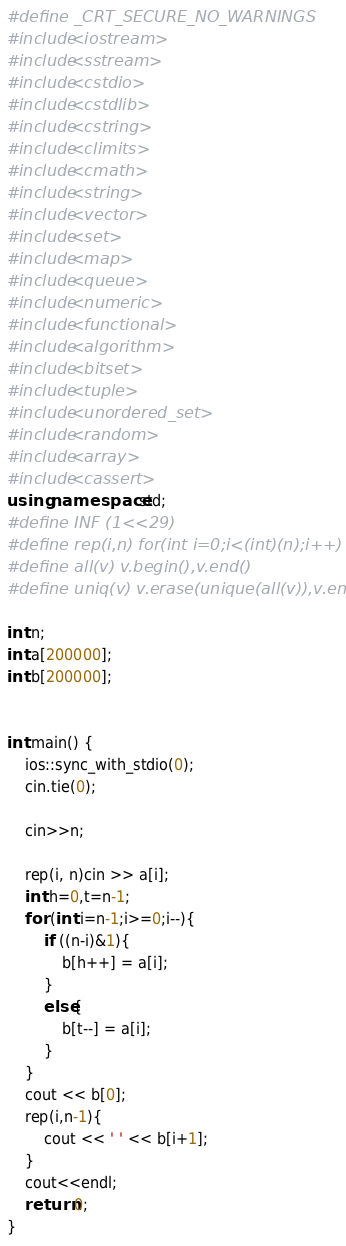Convert code to text. <code><loc_0><loc_0><loc_500><loc_500><_C++_>#define _CRT_SECURE_NO_WARNINGS
#include<iostream>
#include<sstream>
#include<cstdio>
#include<cstdlib>
#include<cstring>
#include<climits>
#include<cmath>
#include<string>
#include<vector>
#include<set>
#include<map>
#include<queue>
#include<numeric>
#include<functional>
#include<algorithm>
#include<bitset>
#include<tuple>
#include<unordered_set>
#include<random>
#include<array>
#include<cassert>
using namespace std;
#define INF (1<<29)
#define rep(i,n) for(int i=0;i<(int)(n);i++)
#define all(v) v.begin(),v.end()
#define uniq(v) v.erase(unique(all(v)),v.end())

int n;
int a[200000];
int b[200000];


int main() {
	ios::sync_with_stdio(0);
	cin.tie(0);

	cin>>n;

	rep(i, n)cin >> a[i];
	int h=0,t=n-1;
	for (int i=n-1;i>=0;i--){
		if ((n-i)&1){
			b[h++] = a[i];
		}
		else{
			b[t--] = a[i];
		}
	}
	cout << b[0];
	rep(i,n-1){
		cout << ' ' << b[i+1];
	}
	cout<<endl;
	return 0;
}</code> 